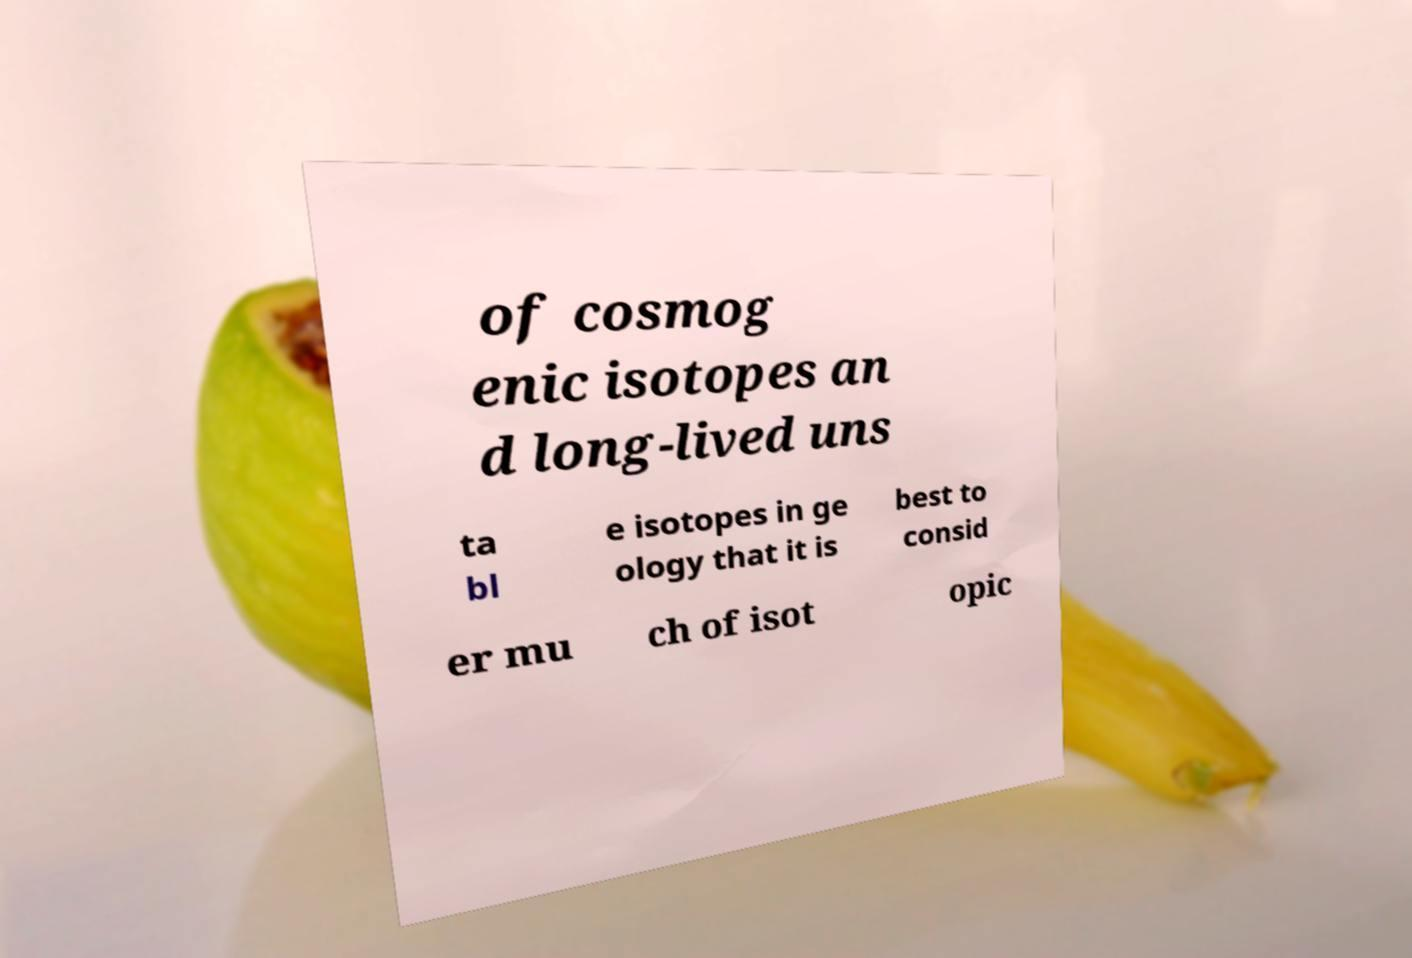Please identify and transcribe the text found in this image. of cosmog enic isotopes an d long-lived uns ta bl e isotopes in ge ology that it is best to consid er mu ch of isot opic 